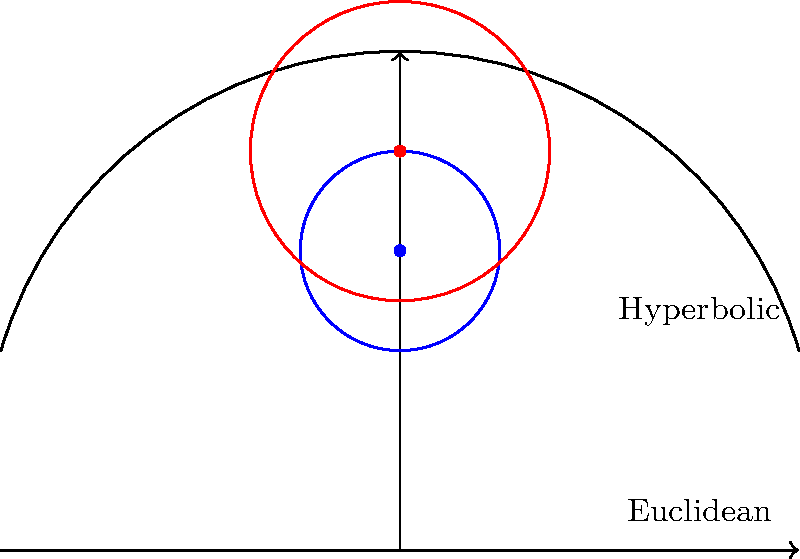In the diagram above, two circles are shown: a blue circle in Euclidean geometry and a red circle in hyperbolic geometry (using the upper half-plane model). Both circles have the same hyperbolic radius. If the area of the blue circle in Euclidean geometry is $A_E$ and the area of the red circle in hyperbolic geometry is $A_H$, which of the following statements is true?

a) $A_E > A_H$
b) $A_E < A_H$
c) $A_E = A_H$
d) The relationship cannot be determined without knowing the specific radius Let's approach this step-by-step:

1) In Euclidean geometry, the area of a circle with radius $r$ is given by $A_E = \pi r^2$.

2) In hyperbolic geometry (upper half-plane model), the area of a circle with hyperbolic radius $R$ is given by:

   $A_H = 4\pi \sinh^2(\frac{R}{2})$

   where $\sinh$ is the hyperbolic sine function.

3) The hyperbolic sine function grows exponentially, much faster than the square function in the Euclidean formula.

4) This means that for small radii, the Euclidean area might be larger, but as the radius increases, the hyperbolic area will quickly overtake the Euclidean area.

5) Without knowing the specific radius, we cannot determine which area is larger.

6) However, we can say that for sufficiently large radii, the hyperbolic area will always be larger than the Euclidean area.

Therefore, without knowing the specific radius of the circles, we cannot determine the relationship between $A_E$ and $A_H$.
Answer: d) The relationship cannot be determined without knowing the specific radius 